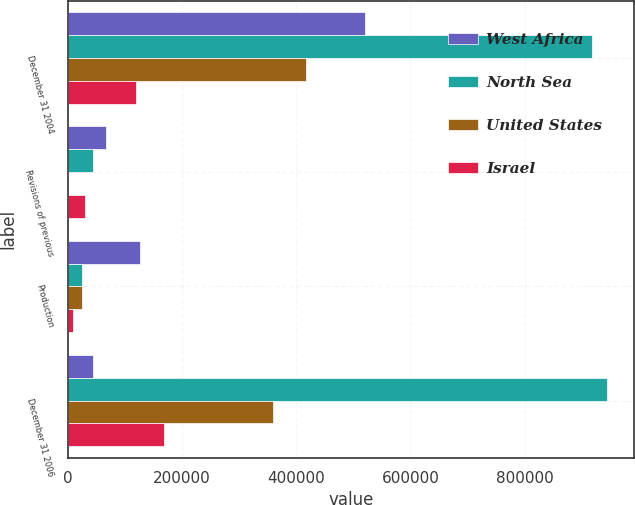Convert chart. <chart><loc_0><loc_0><loc_500><loc_500><stacked_bar_chart><ecel><fcel>December 31 2004<fcel>Revisions of previous<fcel>Production<fcel>December 31 2006<nl><fcel>West Africa<fcel>519735<fcel>67003<fcel>125543<fcel>44256<nl><fcel>North Sea<fcel>917409<fcel>44256<fcel>23938<fcel>944699<nl><fcel>United States<fcel>417293<fcel>52<fcel>24228<fcel>359900<nl><fcel>Israel<fcel>119341<fcel>29872<fcel>8321<fcel>167814<nl></chart> 